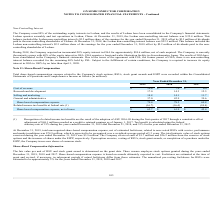According to On Semiconductor's financial document, How much was the total intrinsic value of stock options exercised during the year ended December 31, 2019? According to the financial document, $3.9 million. The relevant text states: "rcised during the year ended December 31, 2019 was $3.9 million. The Company received cash of $1.7 million and $26.2 million from the exercise of stock options and..." Also, How much cash was recieved from the exercise of stock options and the issuance of shares under the ESPP, respectively? The document shows two values: $1.7 million and $26.2 million. From the document: "019 was $3.9 million. The Company received cash of $1.7 million and $26.2 million from the exercise of stock options and the issuance of shares under ..." Also, What is the cost of revenue in 2019? According to the financial document, $10.6 (in millions). The relevant text states: "Cost of revenue $ 10.6 $ 7.0 $ 6.0..." Also, can you calculate: What is the change in Cost of revenue from December 31, 2018 to 2019? Based on the calculation: 10.6-7.0, the result is 3.6 (in millions). This is based on the information: "Cost of revenue $ 10.6 $ 7.0 $ 6.0 Cost of revenue $ 10.6 $ 7.0 $ 6.0..." The key data points involved are: 10.6, 7.0. Also, can you calculate: What is the change in Research and development from year ended December 31, 2018 to 2019? Based on the calculation: 17.0-14.3, the result is 2.7 (in millions). This is based on the information: "Research and development 17.0 14.3 12.5 Research and development 17.0 14.3 12.5..." The key data points involved are: 14.3, 17.0. Also, can you calculate: What is the average Cost of revenue for December 31, 2018 and 2019? To answer this question, I need to perform calculations using the financial data. The calculation is: (10.6+7.0) / 2, which equals 8.8 (in millions). This is based on the information: "Cost of revenue $ 10.6 $ 7.0 $ 6.0 Cost of revenue $ 10.6 $ 7.0 $ 6.0..." The key data points involved are: 10.6, 7.0. 